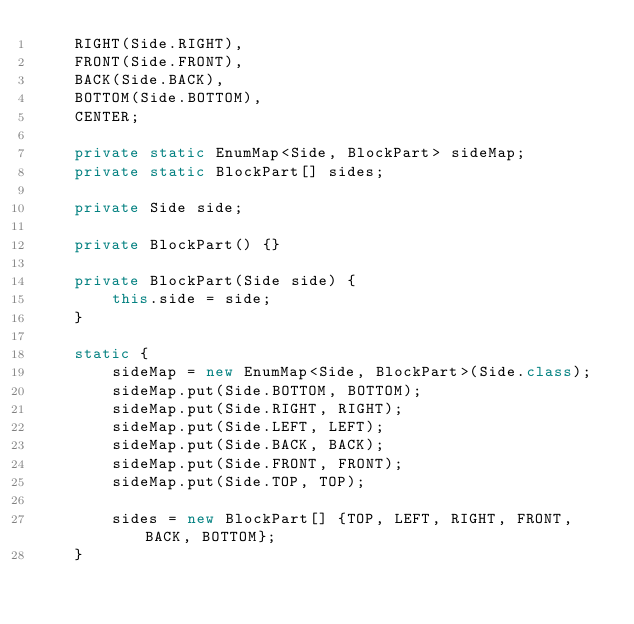<code> <loc_0><loc_0><loc_500><loc_500><_Java_>    RIGHT(Side.RIGHT),
    FRONT(Side.FRONT),
    BACK(Side.BACK),
    BOTTOM(Side.BOTTOM),
    CENTER;

    private static EnumMap<Side, BlockPart> sideMap;
    private static BlockPart[] sides;

    private Side side;

    private BlockPart() {}

    private BlockPart(Side side) {
        this.side = side;
    }

    static {
        sideMap = new EnumMap<Side, BlockPart>(Side.class);
        sideMap.put(Side.BOTTOM, BOTTOM);
        sideMap.put(Side.RIGHT, RIGHT);
        sideMap.put(Side.LEFT, LEFT);
        sideMap.put(Side.BACK, BACK);
        sideMap.put(Side.FRONT, FRONT);
        sideMap.put(Side.TOP, TOP);

        sides = new BlockPart[] {TOP, LEFT, RIGHT, FRONT, BACK, BOTTOM};
    }
</code> 